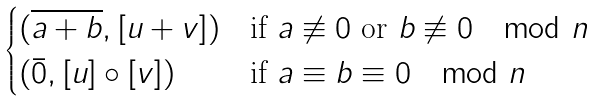Convert formula to latex. <formula><loc_0><loc_0><loc_500><loc_500>\begin{cases} ( \overline { a + b } , [ u + v ] ) & \text {if } a \not \equiv 0 \text { or } b \not \equiv 0 \mod n \\ ( \bar { 0 } , [ u ] \circ [ v ] ) & \text {if } a \equiv b \equiv 0 \mod n \end{cases}</formula> 